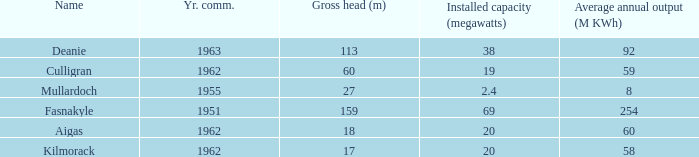What is the Average annual output for Culligran power station with an Installed capacity less than 19? None. 